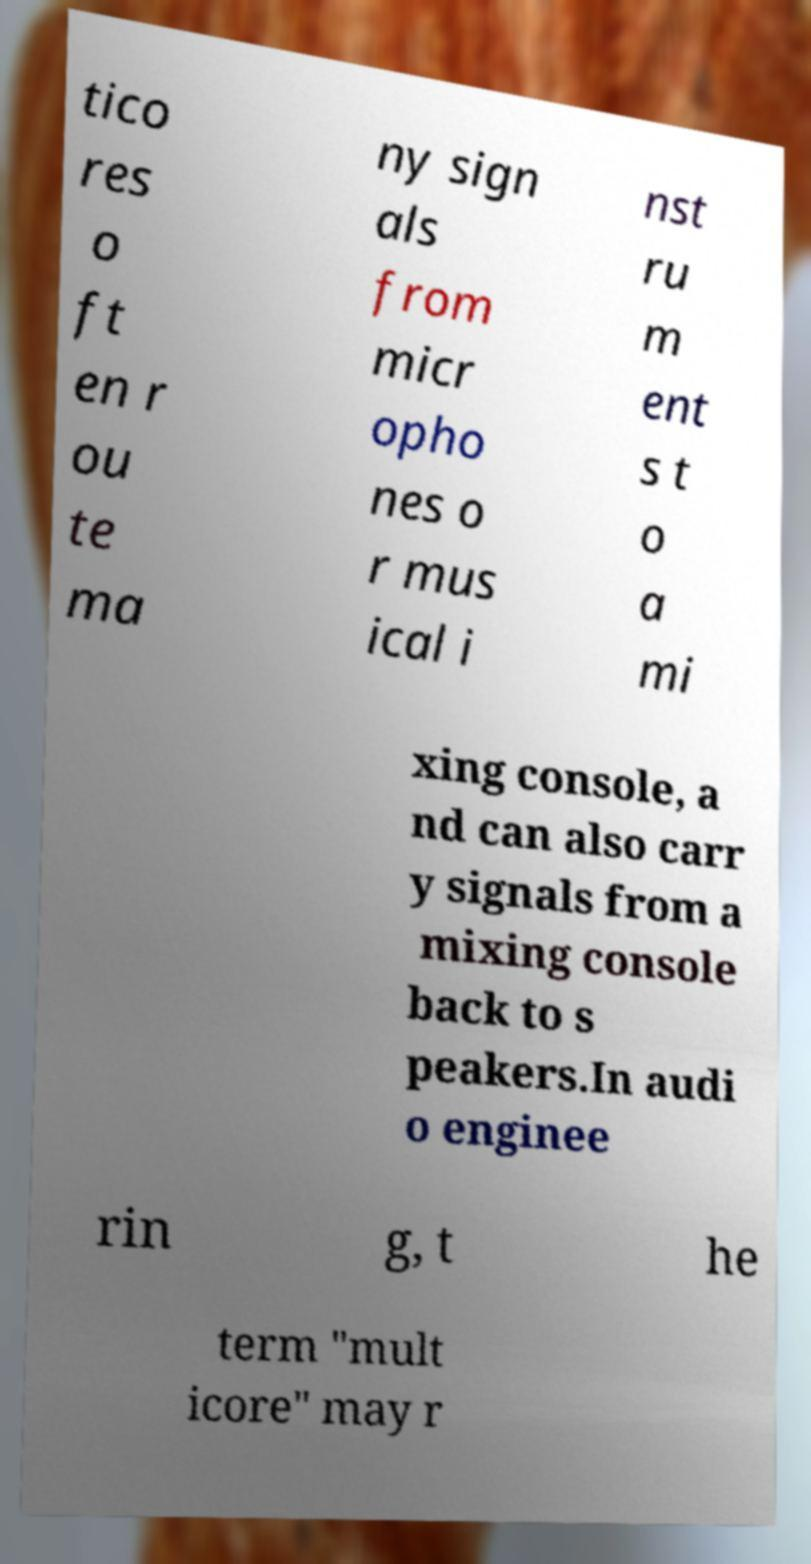Please identify and transcribe the text found in this image. tico res o ft en r ou te ma ny sign als from micr opho nes o r mus ical i nst ru m ent s t o a mi xing console, a nd can also carr y signals from a mixing console back to s peakers.In audi o enginee rin g, t he term "mult icore" may r 